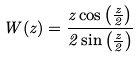<formula> <loc_0><loc_0><loc_500><loc_500>W ( z ) = \frac { z \cos \left ( \frac { z } { 2 } \right ) } { 2 \sin \left ( \frac { z } { 2 } \right ) }</formula> 